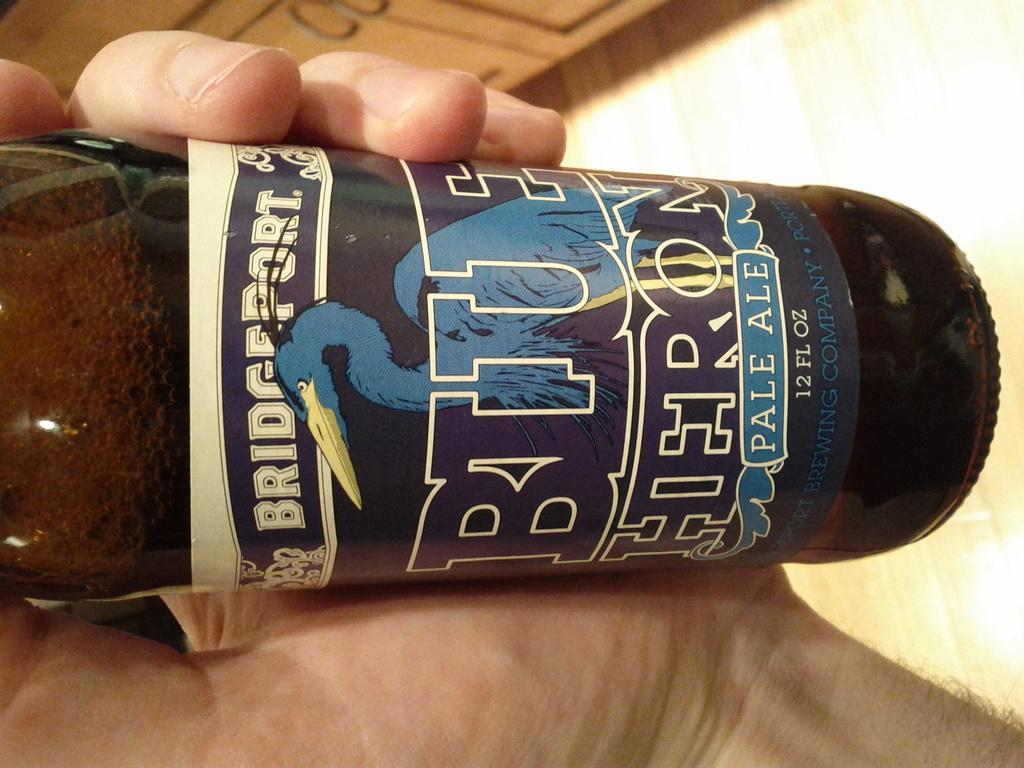Provide a one-sentence caption for the provided image. A bottle of Bridegport Blue Pale Ale beer being held in a man's hand. 